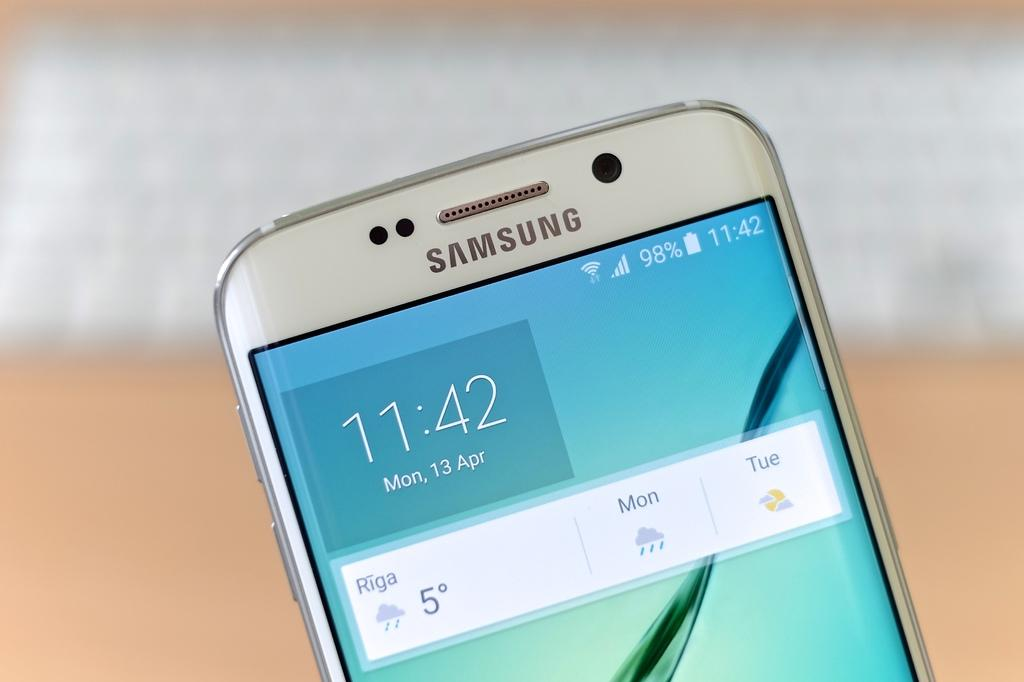<image>
Give a short and clear explanation of the subsequent image. the time on the phone says 11:42 on it 